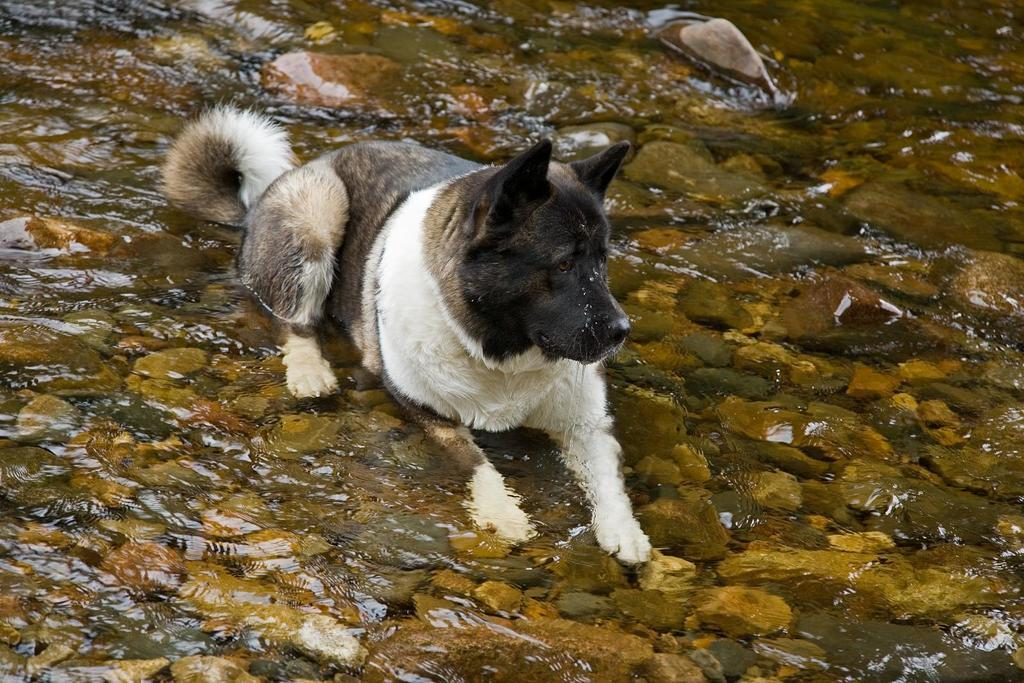What animal can be seen in the image? There is a dog in the image. Where is the dog located in the image? The dog is sitting on stones in the water. What can be seen in the water in the background of the image? There are stones in the water in the background of the image. What type of clam is visible in the image? There is no clam present in the image; it features a dog sitting on stones in the water. What grade is the dog in the image? Dogs do not attend school or have grades; they are not human. 